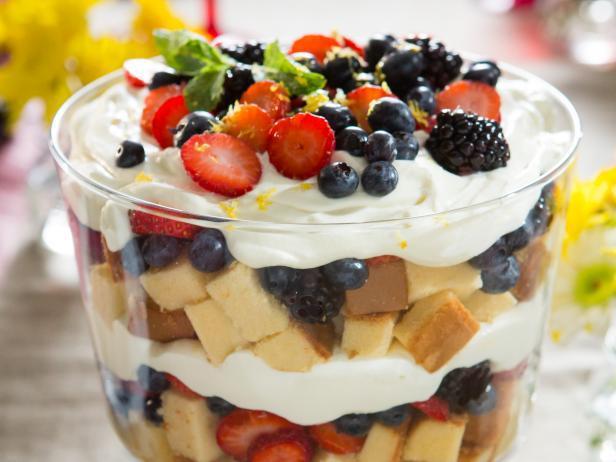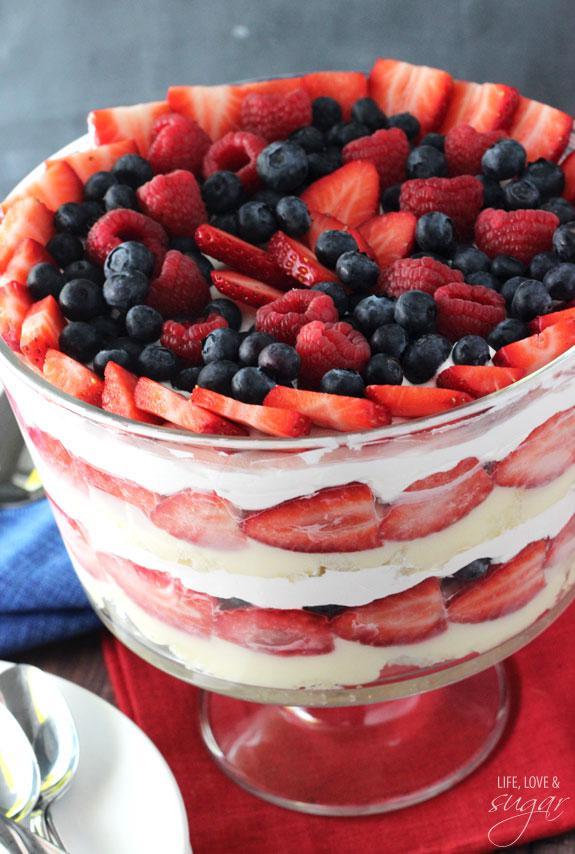The first image is the image on the left, the second image is the image on the right. For the images shown, is this caption "There is an eating utensil next to a bowl of dessert." true? Answer yes or no. Yes. 